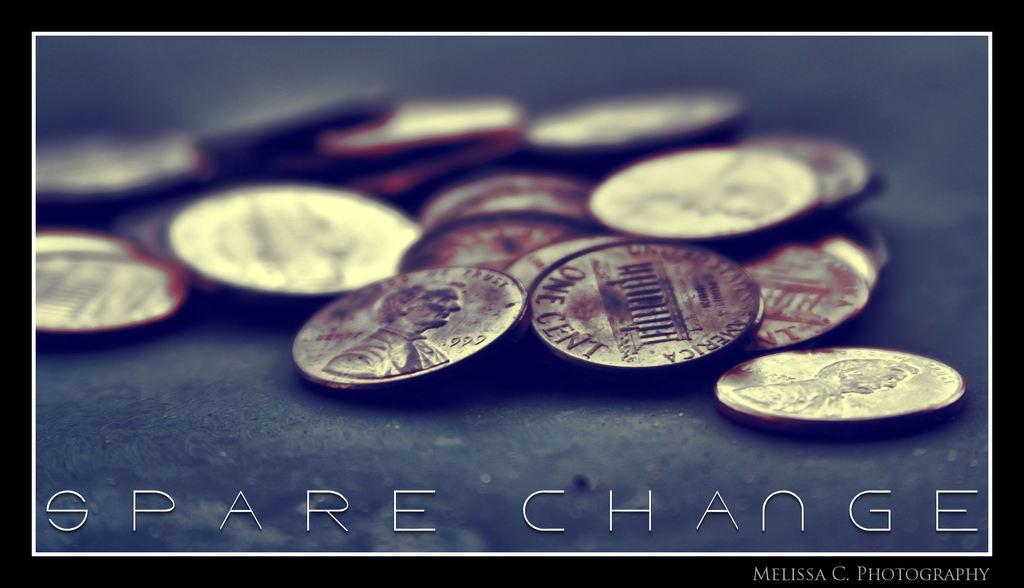What does the title say?
Your response must be concise. Spare change. 